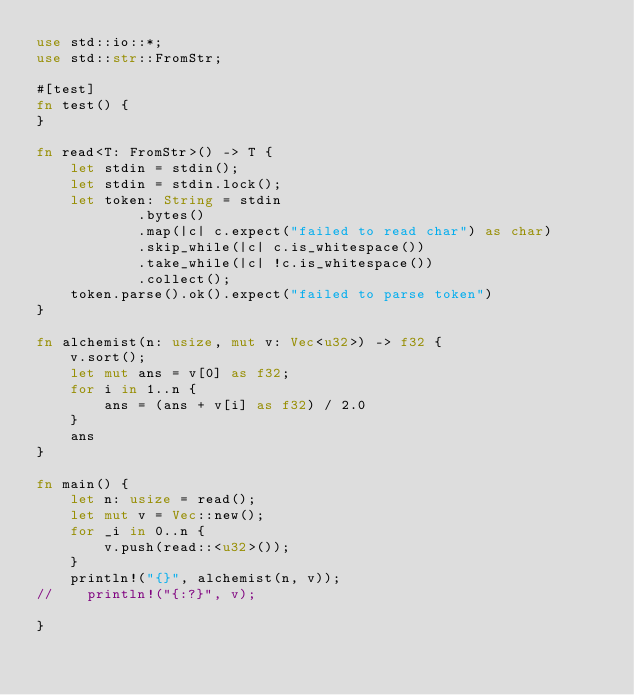Convert code to text. <code><loc_0><loc_0><loc_500><loc_500><_Rust_>use std::io::*;
use std::str::FromStr;

#[test]
fn test() {
}

fn read<T: FromStr>() -> T {
    let stdin = stdin();
    let stdin = stdin.lock();
    let token: String = stdin
            .bytes()
            .map(|c| c.expect("failed to read char") as char)
            .skip_while(|c| c.is_whitespace())
            .take_while(|c| !c.is_whitespace())
            .collect();
    token.parse().ok().expect("failed to parse token")
}

fn alchemist(n: usize, mut v: Vec<u32>) -> f32 {
    v.sort();
    let mut ans = v[0] as f32;
    for i in 1..n {
        ans = (ans + v[i] as f32) / 2.0
    }
    ans 
}

fn main() {
    let n: usize = read();
    let mut v = Vec::new();
    for _i in 0..n {
        v.push(read::<u32>());
    }
    println!("{}", alchemist(n, v));
//    println!("{:?}", v);

}

</code> 